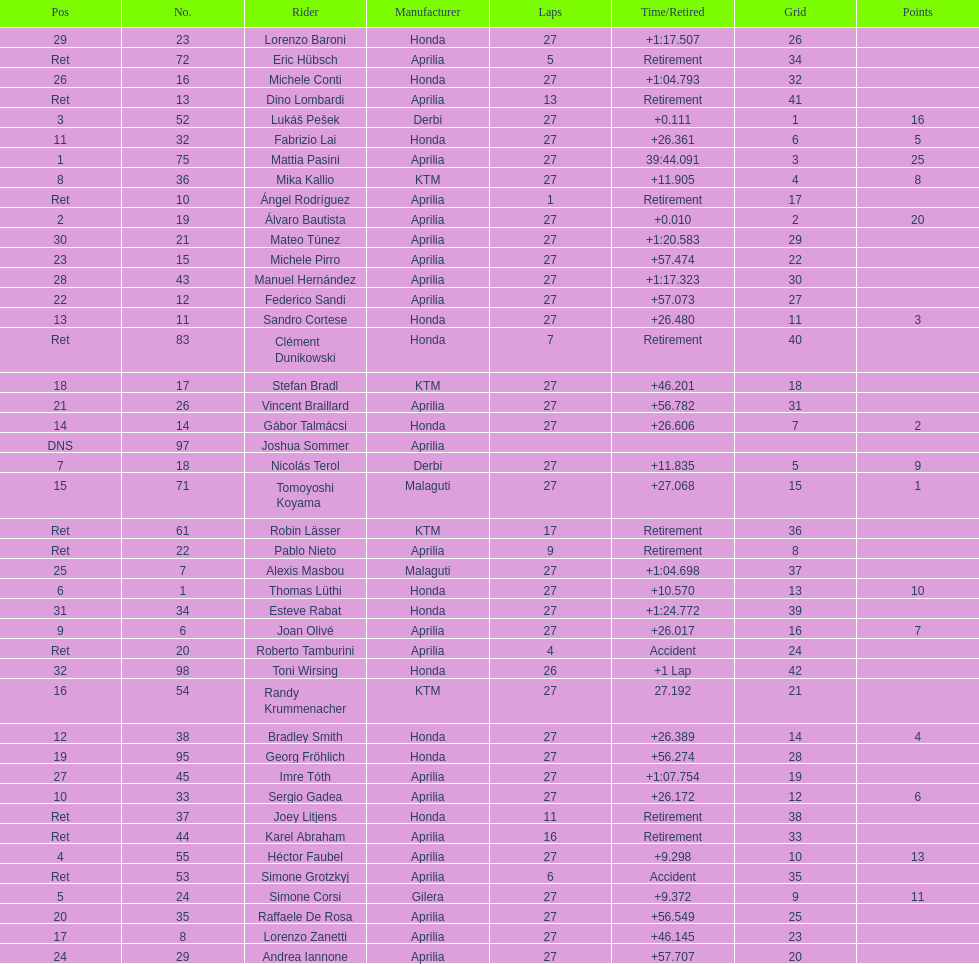How many competitors avoided using aprilia or honda motorcycles? 9. 